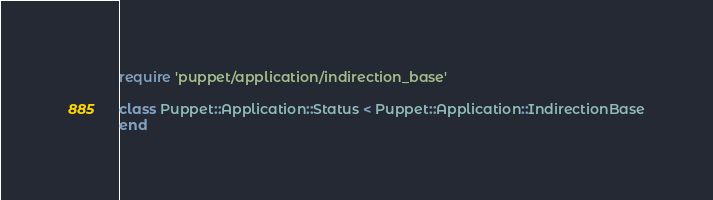Convert code to text. <code><loc_0><loc_0><loc_500><loc_500><_Ruby_>require 'puppet/application/indirection_base'

class Puppet::Application::Status < Puppet::Application::IndirectionBase
end
</code> 